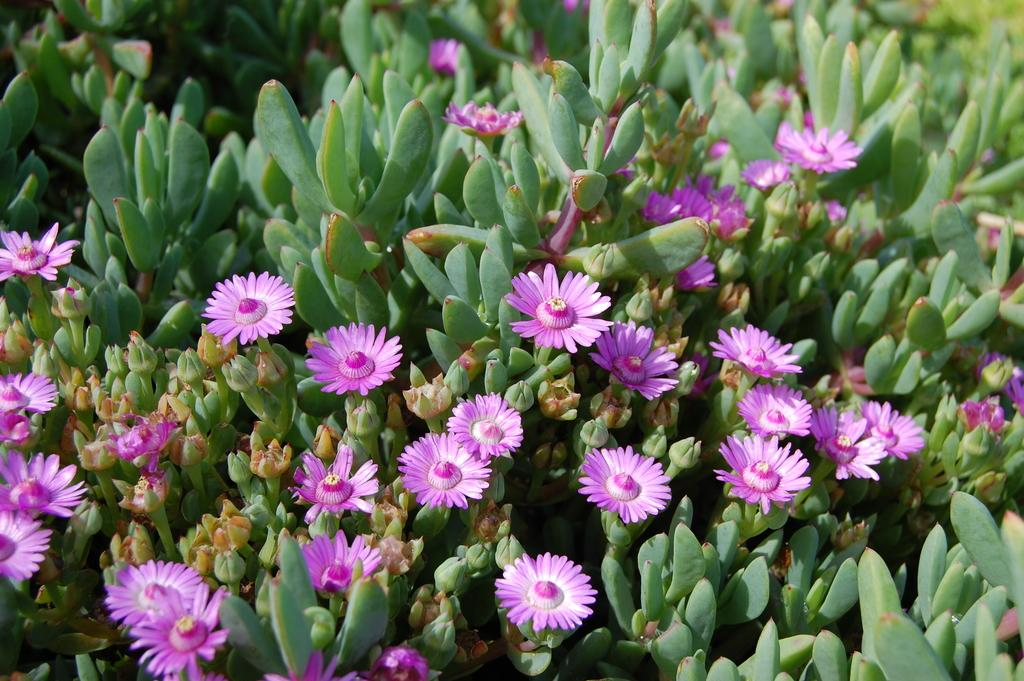What type of plant life is visible in the image? There are flowers, buds, and leaves in the image. Can you describe the different stages of growth represented in the image? The image shows flowers, which are fully bloomed, and buds, which are in the process of blooming. Are there any other parts of the plants visible in the image? Yes, there are leaves present in the image. How many people are sleeping in the cemetery in the image? There is no cemetery or people sleeping in the image; it features plant life. What type of drain is visible in the image? There is no drain present in the image; it features plant life. 